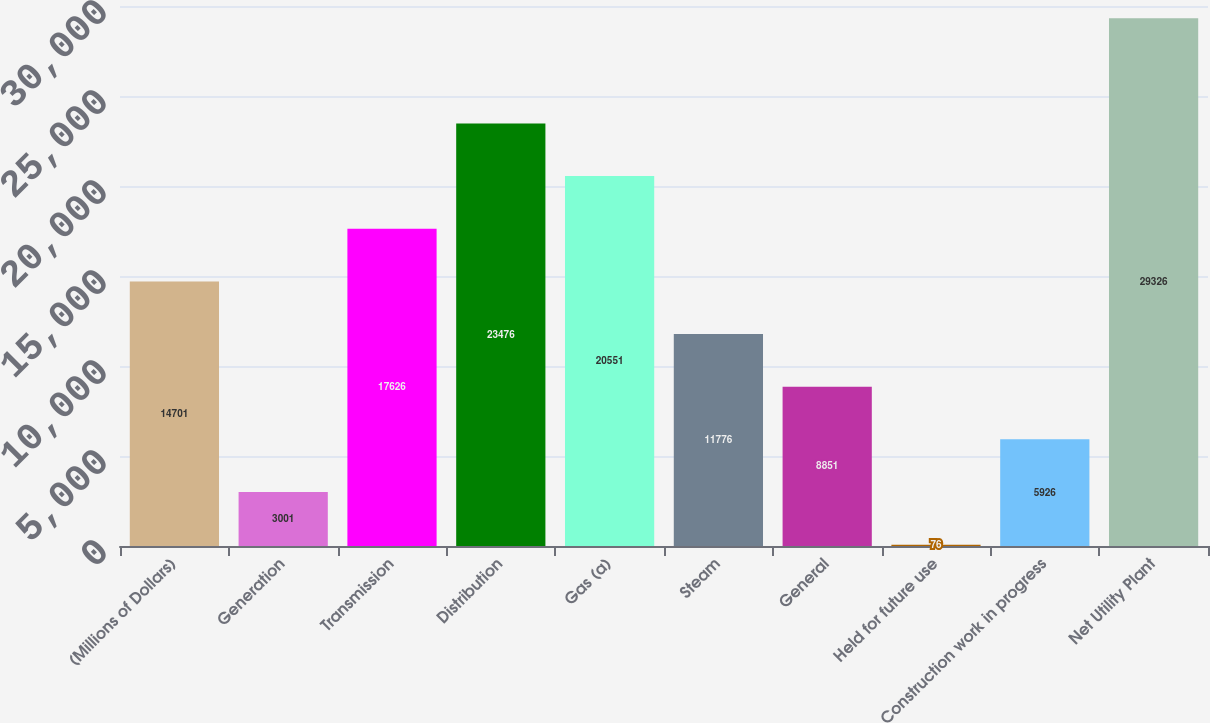Convert chart. <chart><loc_0><loc_0><loc_500><loc_500><bar_chart><fcel>(Millions of Dollars)<fcel>Generation<fcel>Transmission<fcel>Distribution<fcel>Gas (a)<fcel>Steam<fcel>General<fcel>Held for future use<fcel>Construction work in progress<fcel>Net Utility Plant<nl><fcel>14701<fcel>3001<fcel>17626<fcel>23476<fcel>20551<fcel>11776<fcel>8851<fcel>76<fcel>5926<fcel>29326<nl></chart> 